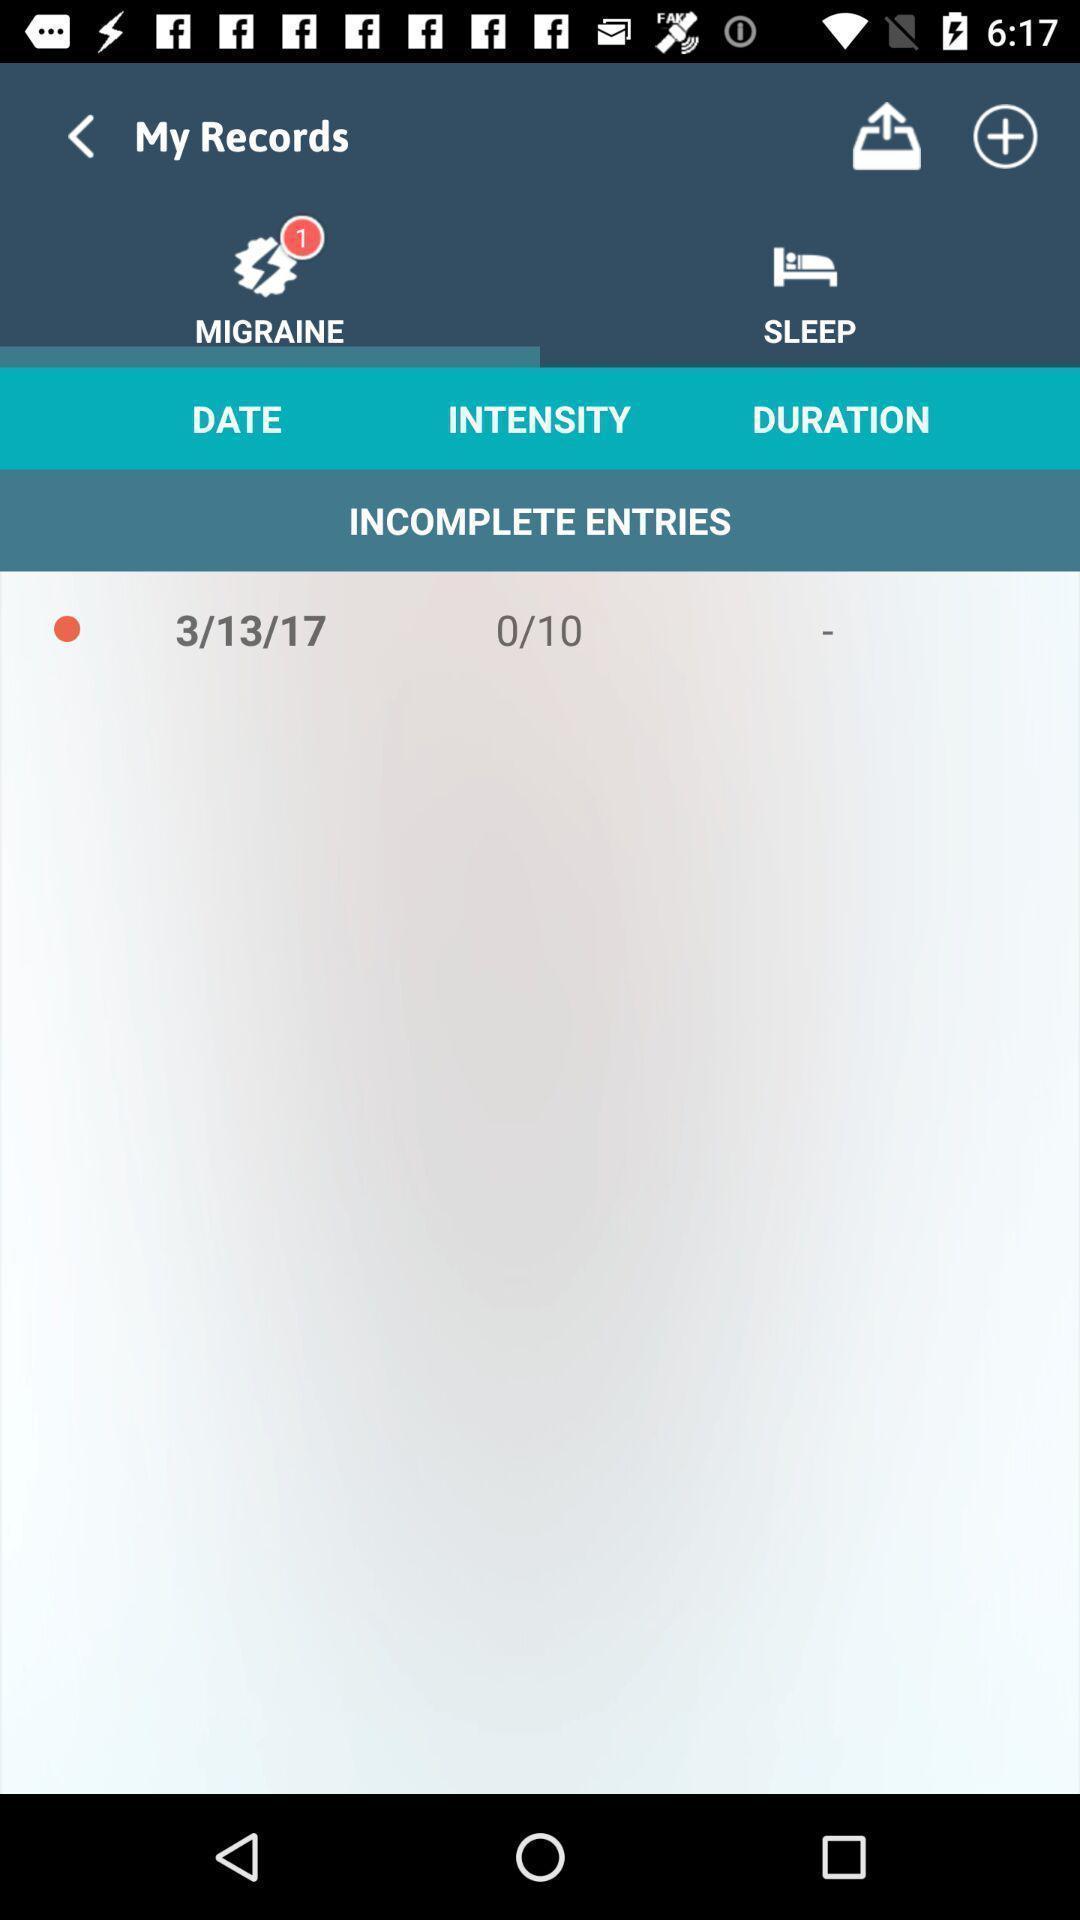What is the overall content of this screenshot? Screen showing my records page. 